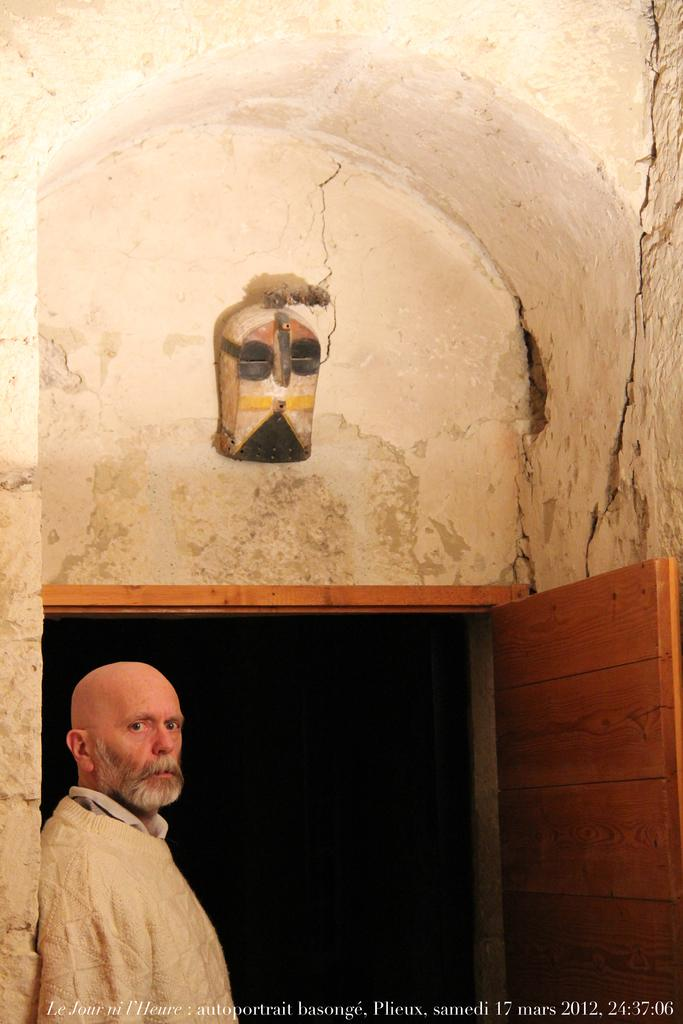What is the main subject of the image? There is a person standing in the image. What can be seen in the background of the image? There is a wall and a door in the background of the image. What type of cheese is stored in the jar on the wall in the image? There is no jar or cheese present in the image. 